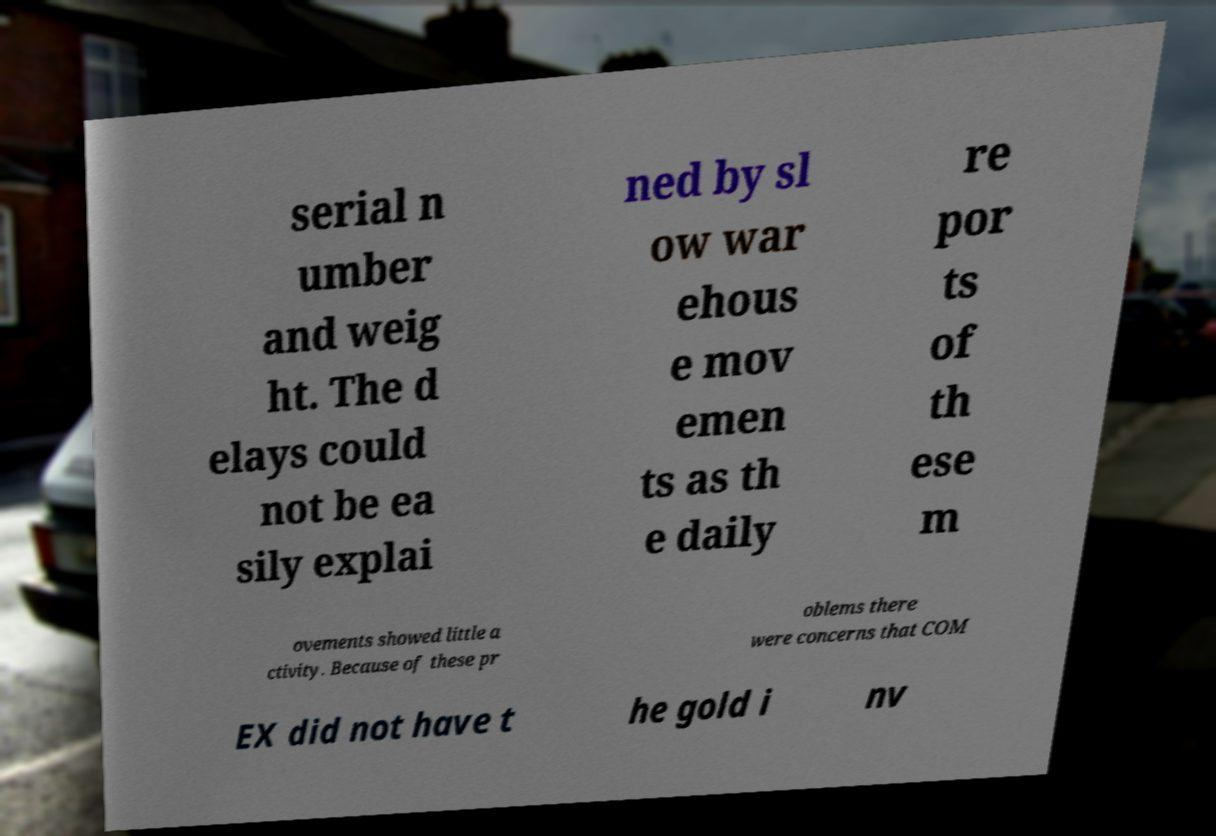For documentation purposes, I need the text within this image transcribed. Could you provide that? serial n umber and weig ht. The d elays could not be ea sily explai ned by sl ow war ehous e mov emen ts as th e daily re por ts of th ese m ovements showed little a ctivity. Because of these pr oblems there were concerns that COM EX did not have t he gold i nv 